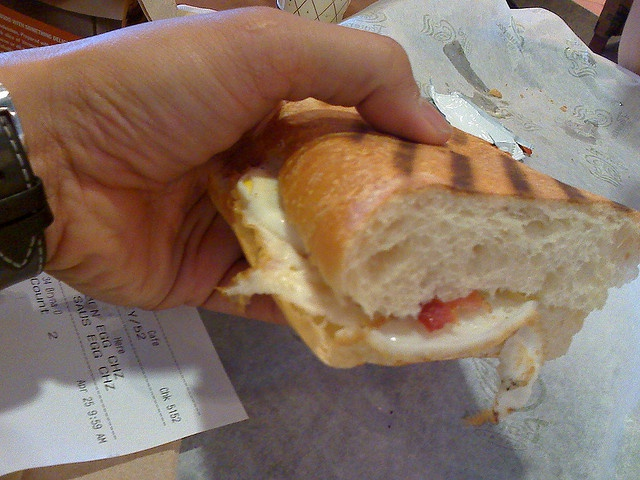Describe the objects in this image and their specific colors. I can see sandwich in black, tan, gray, olive, and darkgray tones and people in black, maroon, gray, and brown tones in this image. 